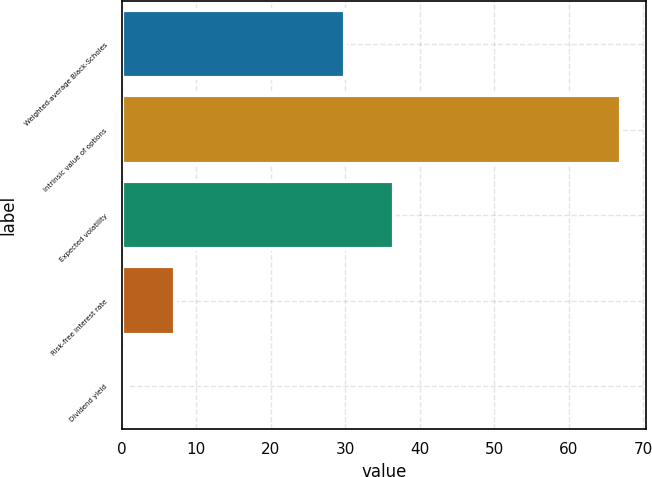<chart> <loc_0><loc_0><loc_500><loc_500><bar_chart><fcel>Weighted-average Black-Scholes<fcel>Intrinsic value of options<fcel>Expected volatility<fcel>Risk-free interest rate<fcel>Dividend yield<nl><fcel>29.92<fcel>67<fcel>36.56<fcel>7.2<fcel>0.56<nl></chart> 